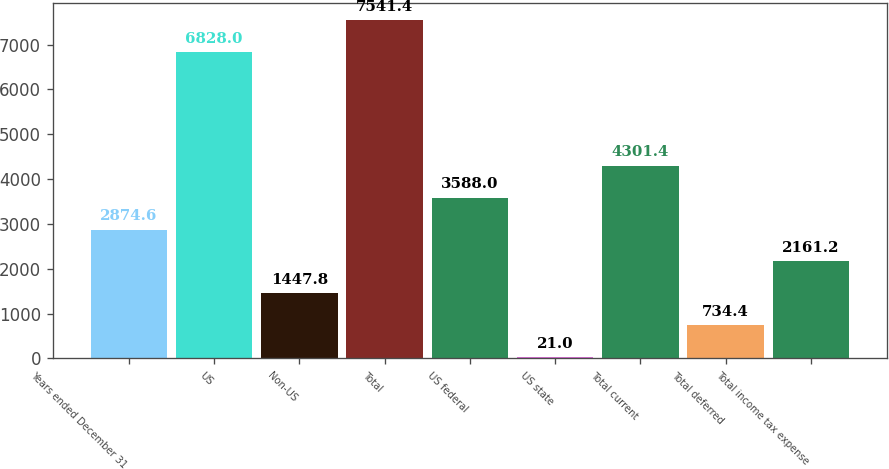Convert chart to OTSL. <chart><loc_0><loc_0><loc_500><loc_500><bar_chart><fcel>Years ended December 31<fcel>US<fcel>Non-US<fcel>Total<fcel>US federal<fcel>US state<fcel>Total current<fcel>Total deferred<fcel>Total income tax expense<nl><fcel>2874.6<fcel>6828<fcel>1447.8<fcel>7541.4<fcel>3588<fcel>21<fcel>4301.4<fcel>734.4<fcel>2161.2<nl></chart> 